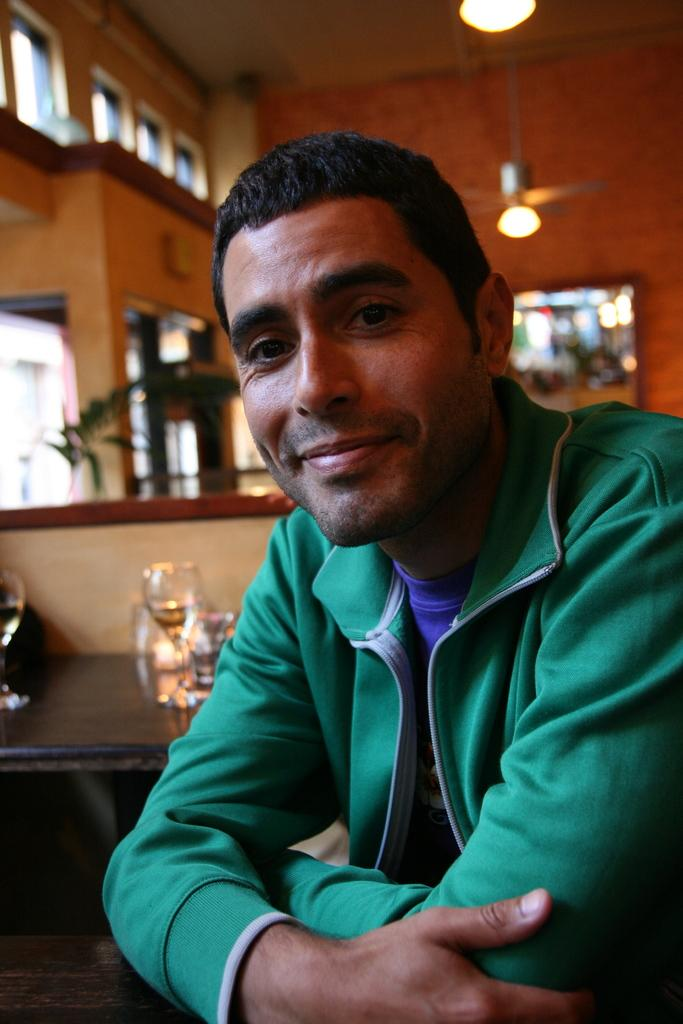Who is present in the image? There is a man in the image. What is the man wearing in the image? The man is wearing a green jacket. Can you describe the background of the image? The background of the man is blurred. How many chairs can be seen in the image? There are no chairs visible in the image. What type of string is being used by the man in the image? There is no string present in the image. 